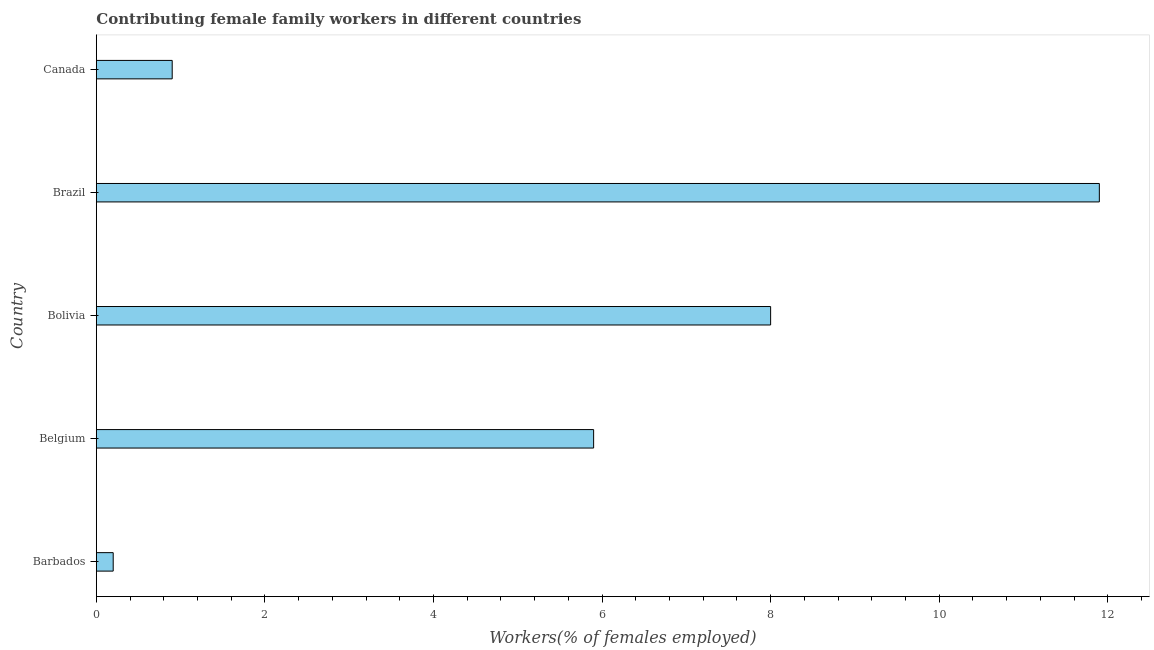Does the graph contain grids?
Your answer should be compact. No. What is the title of the graph?
Keep it short and to the point. Contributing female family workers in different countries. What is the label or title of the X-axis?
Provide a short and direct response. Workers(% of females employed). What is the contributing female family workers in Brazil?
Offer a very short reply. 11.9. Across all countries, what is the maximum contributing female family workers?
Provide a succinct answer. 11.9. Across all countries, what is the minimum contributing female family workers?
Ensure brevity in your answer.  0.2. In which country was the contributing female family workers minimum?
Give a very brief answer. Barbados. What is the sum of the contributing female family workers?
Keep it short and to the point. 26.9. What is the difference between the contributing female family workers in Belgium and Brazil?
Offer a very short reply. -6. What is the average contributing female family workers per country?
Give a very brief answer. 5.38. What is the median contributing female family workers?
Provide a succinct answer. 5.9. In how many countries, is the contributing female family workers greater than 2 %?
Your answer should be very brief. 3. What is the ratio of the contributing female family workers in Barbados to that in Brazil?
Your response must be concise. 0.02. Is the contributing female family workers in Bolivia less than that in Brazil?
Provide a succinct answer. Yes. What is the difference between the highest and the lowest contributing female family workers?
Provide a succinct answer. 11.7. How many bars are there?
Your answer should be very brief. 5. Are all the bars in the graph horizontal?
Make the answer very short. Yes. What is the difference between two consecutive major ticks on the X-axis?
Give a very brief answer. 2. What is the Workers(% of females employed) in Barbados?
Provide a succinct answer. 0.2. What is the Workers(% of females employed) in Belgium?
Make the answer very short. 5.9. What is the Workers(% of females employed) in Brazil?
Keep it short and to the point. 11.9. What is the Workers(% of females employed) in Canada?
Your answer should be very brief. 0.9. What is the difference between the Workers(% of females employed) in Barbados and Belgium?
Your answer should be very brief. -5.7. What is the difference between the Workers(% of females employed) in Barbados and Canada?
Your response must be concise. -0.7. What is the difference between the Workers(% of females employed) in Belgium and Bolivia?
Your answer should be very brief. -2.1. What is the difference between the Workers(% of females employed) in Bolivia and Canada?
Keep it short and to the point. 7.1. What is the ratio of the Workers(% of females employed) in Barbados to that in Belgium?
Give a very brief answer. 0.03. What is the ratio of the Workers(% of females employed) in Barbados to that in Bolivia?
Keep it short and to the point. 0.03. What is the ratio of the Workers(% of females employed) in Barbados to that in Brazil?
Ensure brevity in your answer.  0.02. What is the ratio of the Workers(% of females employed) in Barbados to that in Canada?
Your answer should be compact. 0.22. What is the ratio of the Workers(% of females employed) in Belgium to that in Bolivia?
Provide a short and direct response. 0.74. What is the ratio of the Workers(% of females employed) in Belgium to that in Brazil?
Offer a very short reply. 0.5. What is the ratio of the Workers(% of females employed) in Belgium to that in Canada?
Your answer should be compact. 6.56. What is the ratio of the Workers(% of females employed) in Bolivia to that in Brazil?
Offer a very short reply. 0.67. What is the ratio of the Workers(% of females employed) in Bolivia to that in Canada?
Your answer should be compact. 8.89. What is the ratio of the Workers(% of females employed) in Brazil to that in Canada?
Give a very brief answer. 13.22. 